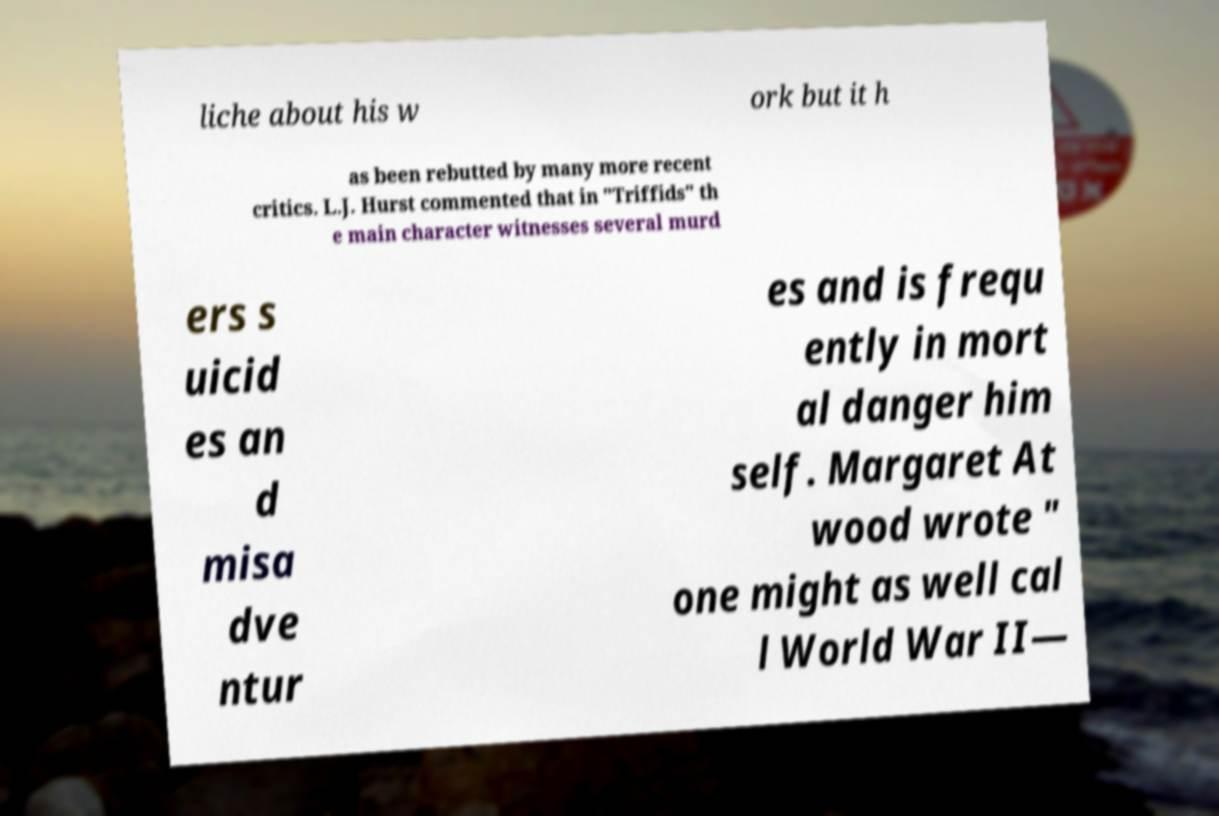For documentation purposes, I need the text within this image transcribed. Could you provide that? liche about his w ork but it h as been rebutted by many more recent critics. L.J. Hurst commented that in "Triffids" th e main character witnesses several murd ers s uicid es an d misa dve ntur es and is frequ ently in mort al danger him self. Margaret At wood wrote " one might as well cal l World War II— 